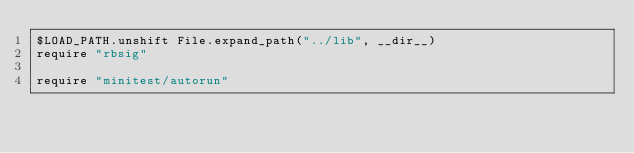Convert code to text. <code><loc_0><loc_0><loc_500><loc_500><_Ruby_>$LOAD_PATH.unshift File.expand_path("../lib", __dir__)
require "rbsig"

require "minitest/autorun"
</code> 